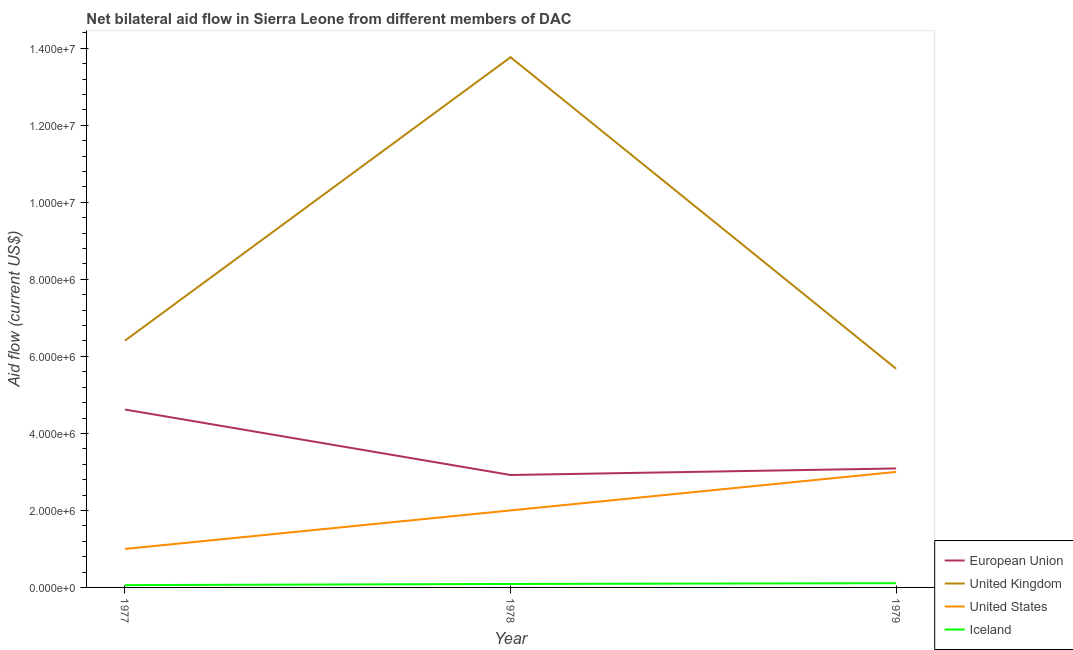How many different coloured lines are there?
Give a very brief answer. 4. What is the amount of aid given by uk in 1977?
Make the answer very short. 6.41e+06. Across all years, what is the maximum amount of aid given by iceland?
Provide a short and direct response. 1.10e+05. Across all years, what is the minimum amount of aid given by eu?
Provide a succinct answer. 2.92e+06. In which year was the amount of aid given by uk maximum?
Provide a short and direct response. 1978. In which year was the amount of aid given by eu minimum?
Your response must be concise. 1978. What is the total amount of aid given by iceland in the graph?
Your answer should be compact. 2.60e+05. What is the difference between the amount of aid given by eu in 1977 and that in 1978?
Your answer should be very brief. 1.70e+06. What is the difference between the amount of aid given by us in 1978 and the amount of aid given by eu in 1979?
Your answer should be very brief. -1.09e+06. What is the average amount of aid given by eu per year?
Ensure brevity in your answer.  3.54e+06. In the year 1977, what is the difference between the amount of aid given by us and amount of aid given by uk?
Provide a short and direct response. -5.41e+06. What is the ratio of the amount of aid given by iceland in 1977 to that in 1978?
Provide a short and direct response. 0.67. Is the difference between the amount of aid given by us in 1978 and 1979 greater than the difference between the amount of aid given by eu in 1978 and 1979?
Ensure brevity in your answer.  No. What is the difference between the highest and the lowest amount of aid given by iceland?
Your answer should be compact. 5.00e+04. Is the sum of the amount of aid given by iceland in 1977 and 1978 greater than the maximum amount of aid given by eu across all years?
Your answer should be very brief. No. Is it the case that in every year, the sum of the amount of aid given by us and amount of aid given by iceland is greater than the sum of amount of aid given by uk and amount of aid given by eu?
Provide a short and direct response. No. Is it the case that in every year, the sum of the amount of aid given by eu and amount of aid given by uk is greater than the amount of aid given by us?
Ensure brevity in your answer.  Yes. Does the amount of aid given by iceland monotonically increase over the years?
Give a very brief answer. Yes. Is the amount of aid given by iceland strictly greater than the amount of aid given by eu over the years?
Offer a very short reply. No. Is the amount of aid given by uk strictly less than the amount of aid given by us over the years?
Give a very brief answer. No. How many lines are there?
Your response must be concise. 4. What is the difference between two consecutive major ticks on the Y-axis?
Your response must be concise. 2.00e+06. Are the values on the major ticks of Y-axis written in scientific E-notation?
Provide a succinct answer. Yes. Does the graph contain any zero values?
Make the answer very short. No. Where does the legend appear in the graph?
Provide a short and direct response. Bottom right. How are the legend labels stacked?
Keep it short and to the point. Vertical. What is the title of the graph?
Make the answer very short. Net bilateral aid flow in Sierra Leone from different members of DAC. What is the label or title of the X-axis?
Provide a short and direct response. Year. What is the Aid flow (current US$) in European Union in 1977?
Your response must be concise. 4.62e+06. What is the Aid flow (current US$) of United Kingdom in 1977?
Keep it short and to the point. 6.41e+06. What is the Aid flow (current US$) in United States in 1977?
Keep it short and to the point. 1.00e+06. What is the Aid flow (current US$) of Iceland in 1977?
Offer a terse response. 6.00e+04. What is the Aid flow (current US$) in European Union in 1978?
Provide a succinct answer. 2.92e+06. What is the Aid flow (current US$) in United Kingdom in 1978?
Offer a terse response. 1.38e+07. What is the Aid flow (current US$) in United States in 1978?
Make the answer very short. 2.00e+06. What is the Aid flow (current US$) of European Union in 1979?
Provide a short and direct response. 3.09e+06. What is the Aid flow (current US$) in United Kingdom in 1979?
Your answer should be compact. 5.68e+06. What is the Aid flow (current US$) in United States in 1979?
Provide a succinct answer. 3.00e+06. Across all years, what is the maximum Aid flow (current US$) of European Union?
Ensure brevity in your answer.  4.62e+06. Across all years, what is the maximum Aid flow (current US$) of United Kingdom?
Make the answer very short. 1.38e+07. Across all years, what is the minimum Aid flow (current US$) in European Union?
Provide a succinct answer. 2.92e+06. Across all years, what is the minimum Aid flow (current US$) in United Kingdom?
Your response must be concise. 5.68e+06. Across all years, what is the minimum Aid flow (current US$) in Iceland?
Keep it short and to the point. 6.00e+04. What is the total Aid flow (current US$) of European Union in the graph?
Your answer should be very brief. 1.06e+07. What is the total Aid flow (current US$) of United Kingdom in the graph?
Your answer should be very brief. 2.59e+07. What is the total Aid flow (current US$) in United States in the graph?
Your answer should be compact. 6.00e+06. What is the difference between the Aid flow (current US$) of European Union in 1977 and that in 1978?
Give a very brief answer. 1.70e+06. What is the difference between the Aid flow (current US$) in United Kingdom in 1977 and that in 1978?
Your answer should be very brief. -7.36e+06. What is the difference between the Aid flow (current US$) in European Union in 1977 and that in 1979?
Offer a terse response. 1.53e+06. What is the difference between the Aid flow (current US$) in United Kingdom in 1977 and that in 1979?
Provide a succinct answer. 7.30e+05. What is the difference between the Aid flow (current US$) in Iceland in 1977 and that in 1979?
Offer a terse response. -5.00e+04. What is the difference between the Aid flow (current US$) in United Kingdom in 1978 and that in 1979?
Your response must be concise. 8.09e+06. What is the difference between the Aid flow (current US$) of Iceland in 1978 and that in 1979?
Make the answer very short. -2.00e+04. What is the difference between the Aid flow (current US$) of European Union in 1977 and the Aid flow (current US$) of United Kingdom in 1978?
Provide a short and direct response. -9.15e+06. What is the difference between the Aid flow (current US$) of European Union in 1977 and the Aid flow (current US$) of United States in 1978?
Your response must be concise. 2.62e+06. What is the difference between the Aid flow (current US$) in European Union in 1977 and the Aid flow (current US$) in Iceland in 1978?
Ensure brevity in your answer.  4.53e+06. What is the difference between the Aid flow (current US$) in United Kingdom in 1977 and the Aid flow (current US$) in United States in 1978?
Offer a terse response. 4.41e+06. What is the difference between the Aid flow (current US$) in United Kingdom in 1977 and the Aid flow (current US$) in Iceland in 1978?
Provide a succinct answer. 6.32e+06. What is the difference between the Aid flow (current US$) of United States in 1977 and the Aid flow (current US$) of Iceland in 1978?
Give a very brief answer. 9.10e+05. What is the difference between the Aid flow (current US$) of European Union in 1977 and the Aid flow (current US$) of United Kingdom in 1979?
Your answer should be compact. -1.06e+06. What is the difference between the Aid flow (current US$) of European Union in 1977 and the Aid flow (current US$) of United States in 1979?
Keep it short and to the point. 1.62e+06. What is the difference between the Aid flow (current US$) of European Union in 1977 and the Aid flow (current US$) of Iceland in 1979?
Offer a terse response. 4.51e+06. What is the difference between the Aid flow (current US$) of United Kingdom in 1977 and the Aid flow (current US$) of United States in 1979?
Offer a very short reply. 3.41e+06. What is the difference between the Aid flow (current US$) in United Kingdom in 1977 and the Aid flow (current US$) in Iceland in 1979?
Your response must be concise. 6.30e+06. What is the difference between the Aid flow (current US$) of United States in 1977 and the Aid flow (current US$) of Iceland in 1979?
Your answer should be very brief. 8.90e+05. What is the difference between the Aid flow (current US$) in European Union in 1978 and the Aid flow (current US$) in United Kingdom in 1979?
Provide a succinct answer. -2.76e+06. What is the difference between the Aid flow (current US$) in European Union in 1978 and the Aid flow (current US$) in United States in 1979?
Give a very brief answer. -8.00e+04. What is the difference between the Aid flow (current US$) of European Union in 1978 and the Aid flow (current US$) of Iceland in 1979?
Keep it short and to the point. 2.81e+06. What is the difference between the Aid flow (current US$) of United Kingdom in 1978 and the Aid flow (current US$) of United States in 1979?
Keep it short and to the point. 1.08e+07. What is the difference between the Aid flow (current US$) of United Kingdom in 1978 and the Aid flow (current US$) of Iceland in 1979?
Make the answer very short. 1.37e+07. What is the difference between the Aid flow (current US$) of United States in 1978 and the Aid flow (current US$) of Iceland in 1979?
Ensure brevity in your answer.  1.89e+06. What is the average Aid flow (current US$) of European Union per year?
Keep it short and to the point. 3.54e+06. What is the average Aid flow (current US$) of United Kingdom per year?
Your response must be concise. 8.62e+06. What is the average Aid flow (current US$) in United States per year?
Provide a succinct answer. 2.00e+06. What is the average Aid flow (current US$) of Iceland per year?
Your answer should be compact. 8.67e+04. In the year 1977, what is the difference between the Aid flow (current US$) in European Union and Aid flow (current US$) in United Kingdom?
Offer a terse response. -1.79e+06. In the year 1977, what is the difference between the Aid flow (current US$) of European Union and Aid flow (current US$) of United States?
Offer a very short reply. 3.62e+06. In the year 1977, what is the difference between the Aid flow (current US$) of European Union and Aid flow (current US$) of Iceland?
Offer a terse response. 4.56e+06. In the year 1977, what is the difference between the Aid flow (current US$) of United Kingdom and Aid flow (current US$) of United States?
Give a very brief answer. 5.41e+06. In the year 1977, what is the difference between the Aid flow (current US$) of United Kingdom and Aid flow (current US$) of Iceland?
Offer a very short reply. 6.35e+06. In the year 1977, what is the difference between the Aid flow (current US$) in United States and Aid flow (current US$) in Iceland?
Give a very brief answer. 9.40e+05. In the year 1978, what is the difference between the Aid flow (current US$) in European Union and Aid flow (current US$) in United Kingdom?
Provide a succinct answer. -1.08e+07. In the year 1978, what is the difference between the Aid flow (current US$) in European Union and Aid flow (current US$) in United States?
Give a very brief answer. 9.20e+05. In the year 1978, what is the difference between the Aid flow (current US$) in European Union and Aid flow (current US$) in Iceland?
Your answer should be compact. 2.83e+06. In the year 1978, what is the difference between the Aid flow (current US$) in United Kingdom and Aid flow (current US$) in United States?
Offer a very short reply. 1.18e+07. In the year 1978, what is the difference between the Aid flow (current US$) in United Kingdom and Aid flow (current US$) in Iceland?
Provide a succinct answer. 1.37e+07. In the year 1978, what is the difference between the Aid flow (current US$) of United States and Aid flow (current US$) of Iceland?
Provide a succinct answer. 1.91e+06. In the year 1979, what is the difference between the Aid flow (current US$) of European Union and Aid flow (current US$) of United Kingdom?
Your response must be concise. -2.59e+06. In the year 1979, what is the difference between the Aid flow (current US$) of European Union and Aid flow (current US$) of United States?
Provide a succinct answer. 9.00e+04. In the year 1979, what is the difference between the Aid flow (current US$) in European Union and Aid flow (current US$) in Iceland?
Your response must be concise. 2.98e+06. In the year 1979, what is the difference between the Aid flow (current US$) in United Kingdom and Aid flow (current US$) in United States?
Your response must be concise. 2.68e+06. In the year 1979, what is the difference between the Aid flow (current US$) in United Kingdom and Aid flow (current US$) in Iceland?
Ensure brevity in your answer.  5.57e+06. In the year 1979, what is the difference between the Aid flow (current US$) of United States and Aid flow (current US$) of Iceland?
Offer a very short reply. 2.89e+06. What is the ratio of the Aid flow (current US$) in European Union in 1977 to that in 1978?
Your answer should be compact. 1.58. What is the ratio of the Aid flow (current US$) in United Kingdom in 1977 to that in 1978?
Your answer should be very brief. 0.47. What is the ratio of the Aid flow (current US$) in Iceland in 1977 to that in 1978?
Your answer should be very brief. 0.67. What is the ratio of the Aid flow (current US$) of European Union in 1977 to that in 1979?
Make the answer very short. 1.5. What is the ratio of the Aid flow (current US$) of United Kingdom in 1977 to that in 1979?
Offer a terse response. 1.13. What is the ratio of the Aid flow (current US$) of Iceland in 1977 to that in 1979?
Provide a succinct answer. 0.55. What is the ratio of the Aid flow (current US$) of European Union in 1978 to that in 1979?
Provide a short and direct response. 0.94. What is the ratio of the Aid flow (current US$) of United Kingdom in 1978 to that in 1979?
Offer a very short reply. 2.42. What is the ratio of the Aid flow (current US$) in Iceland in 1978 to that in 1979?
Ensure brevity in your answer.  0.82. What is the difference between the highest and the second highest Aid flow (current US$) in European Union?
Keep it short and to the point. 1.53e+06. What is the difference between the highest and the second highest Aid flow (current US$) in United Kingdom?
Keep it short and to the point. 7.36e+06. What is the difference between the highest and the second highest Aid flow (current US$) in United States?
Your response must be concise. 1.00e+06. What is the difference between the highest and the lowest Aid flow (current US$) of European Union?
Your response must be concise. 1.70e+06. What is the difference between the highest and the lowest Aid flow (current US$) of United Kingdom?
Your answer should be compact. 8.09e+06. What is the difference between the highest and the lowest Aid flow (current US$) in United States?
Your answer should be compact. 2.00e+06. What is the difference between the highest and the lowest Aid flow (current US$) of Iceland?
Give a very brief answer. 5.00e+04. 